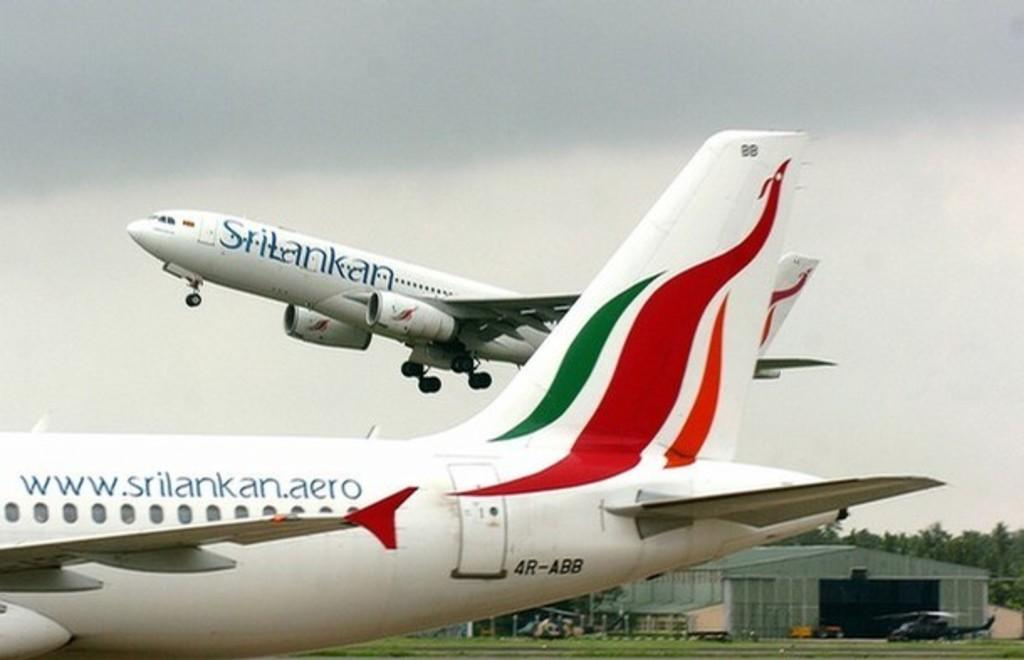<image>
Provide a brief description of the given image. A large plane that says www.srilankanaero on it. 